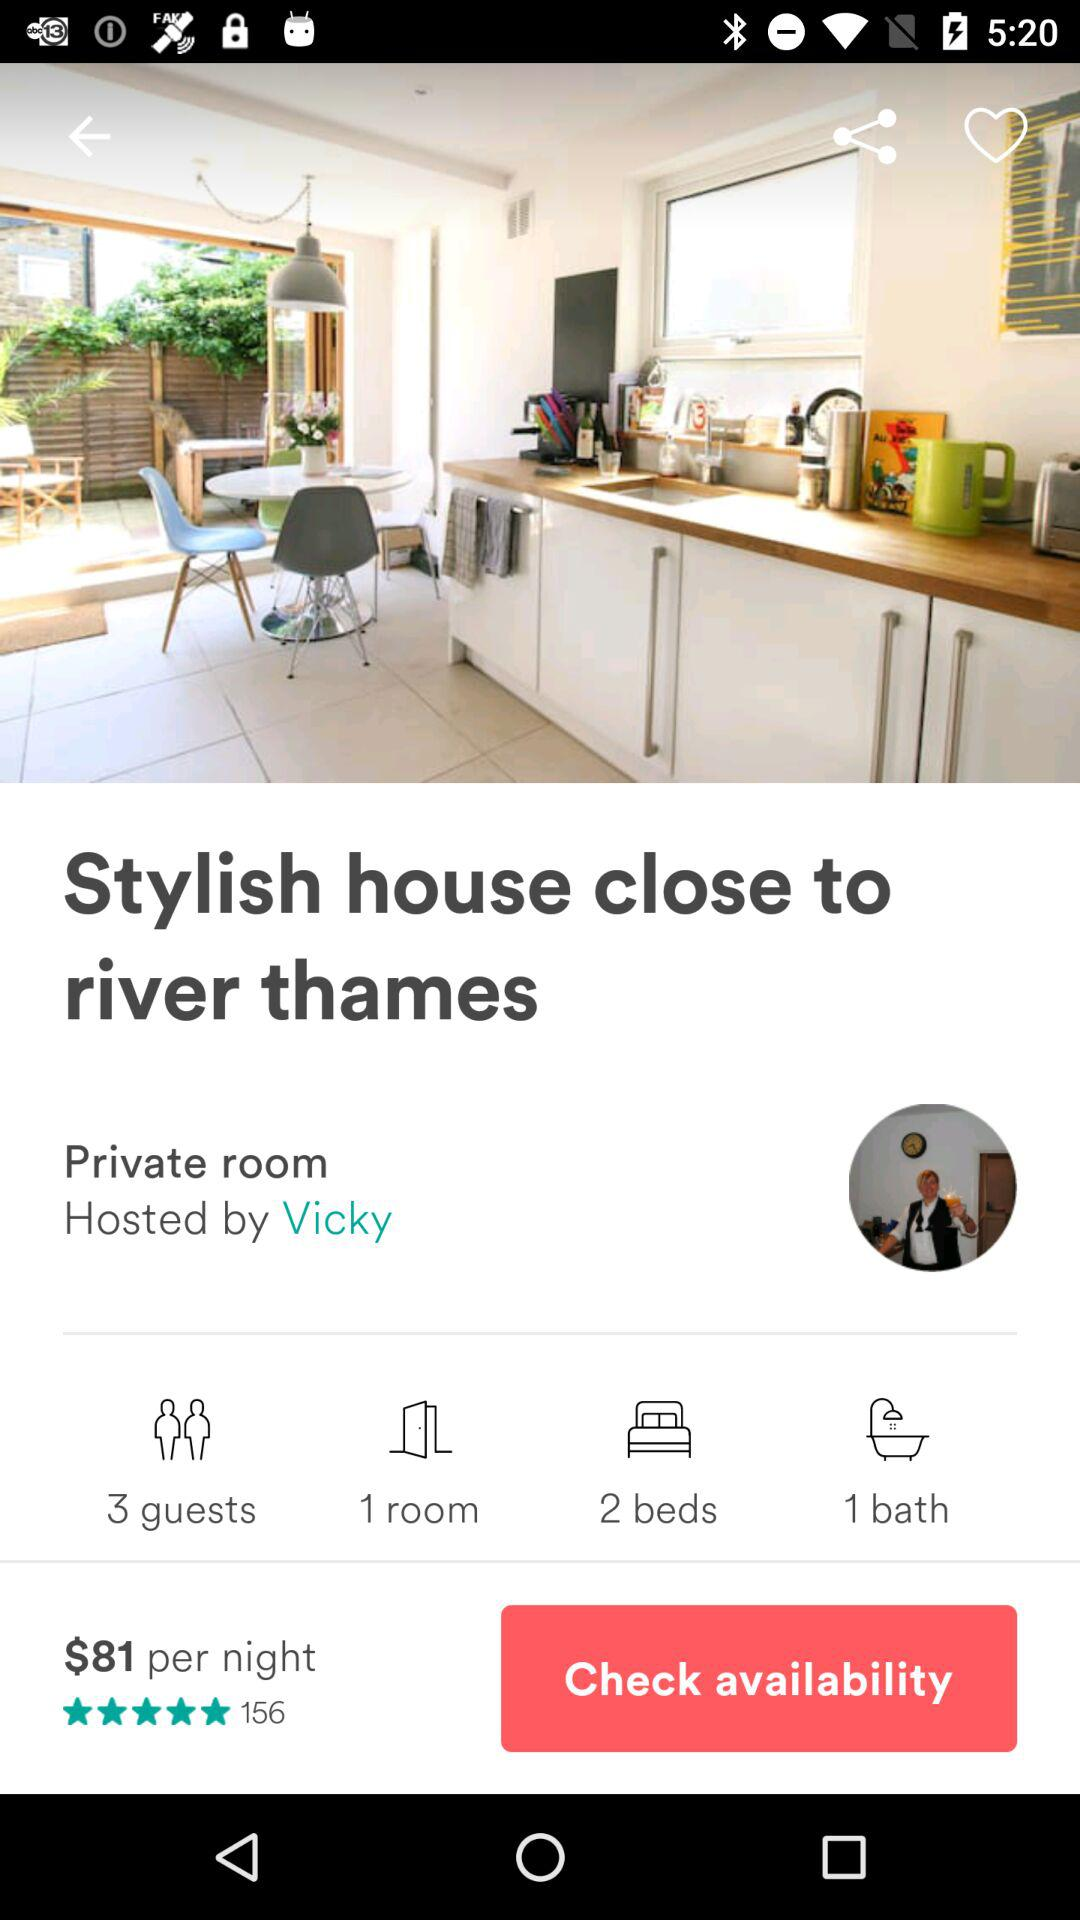What's the price of the room per night? The price of the room per night is $81. 